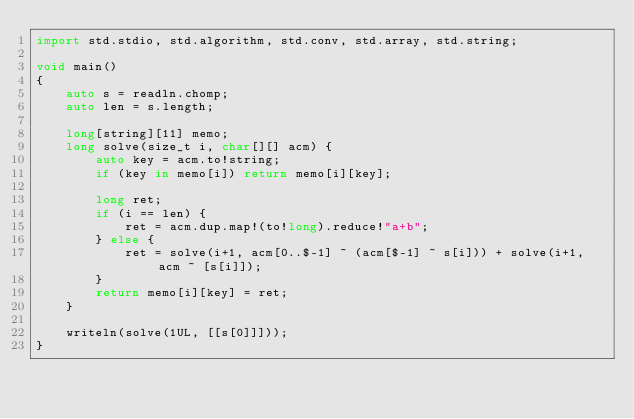Convert code to text. <code><loc_0><loc_0><loc_500><loc_500><_D_>import std.stdio, std.algorithm, std.conv, std.array, std.string;

void main()
{
    auto s = readln.chomp;
    auto len = s.length;

    long[string][11] memo;
    long solve(size_t i, char[][] acm) {
        auto key = acm.to!string;
        if (key in memo[i]) return memo[i][key];

        long ret;
        if (i == len) {
            ret = acm.dup.map!(to!long).reduce!"a+b";
        } else {
            ret = solve(i+1, acm[0..$-1] ~ (acm[$-1] ~ s[i])) + solve(i+1, acm ~ [s[i]]);
        }
        return memo[i][key] = ret;
    }

    writeln(solve(1UL, [[s[0]]]));
}</code> 